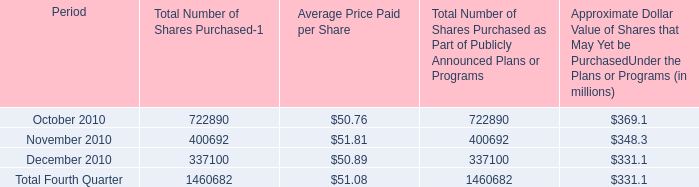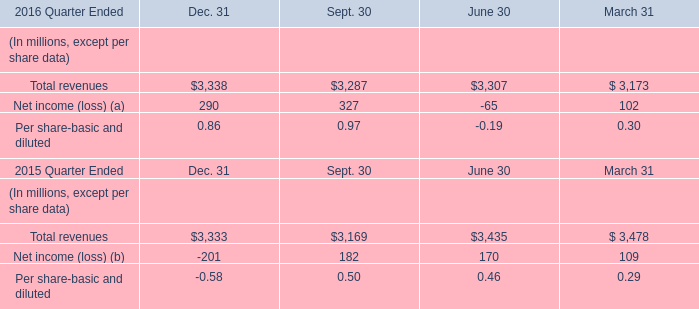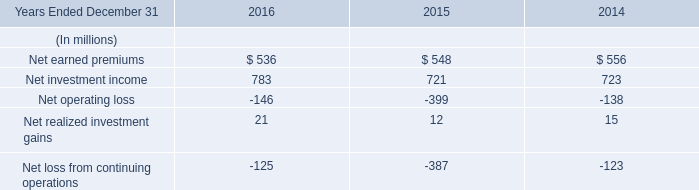What is the ratio of all elements for Net income (loss) (a) that are smaller than 200 to the sum of elements , in 2016? 
Computations: ((-65 + 102) / (((-65 + 102) + 290) + 327))
Answer: 0.05657. 